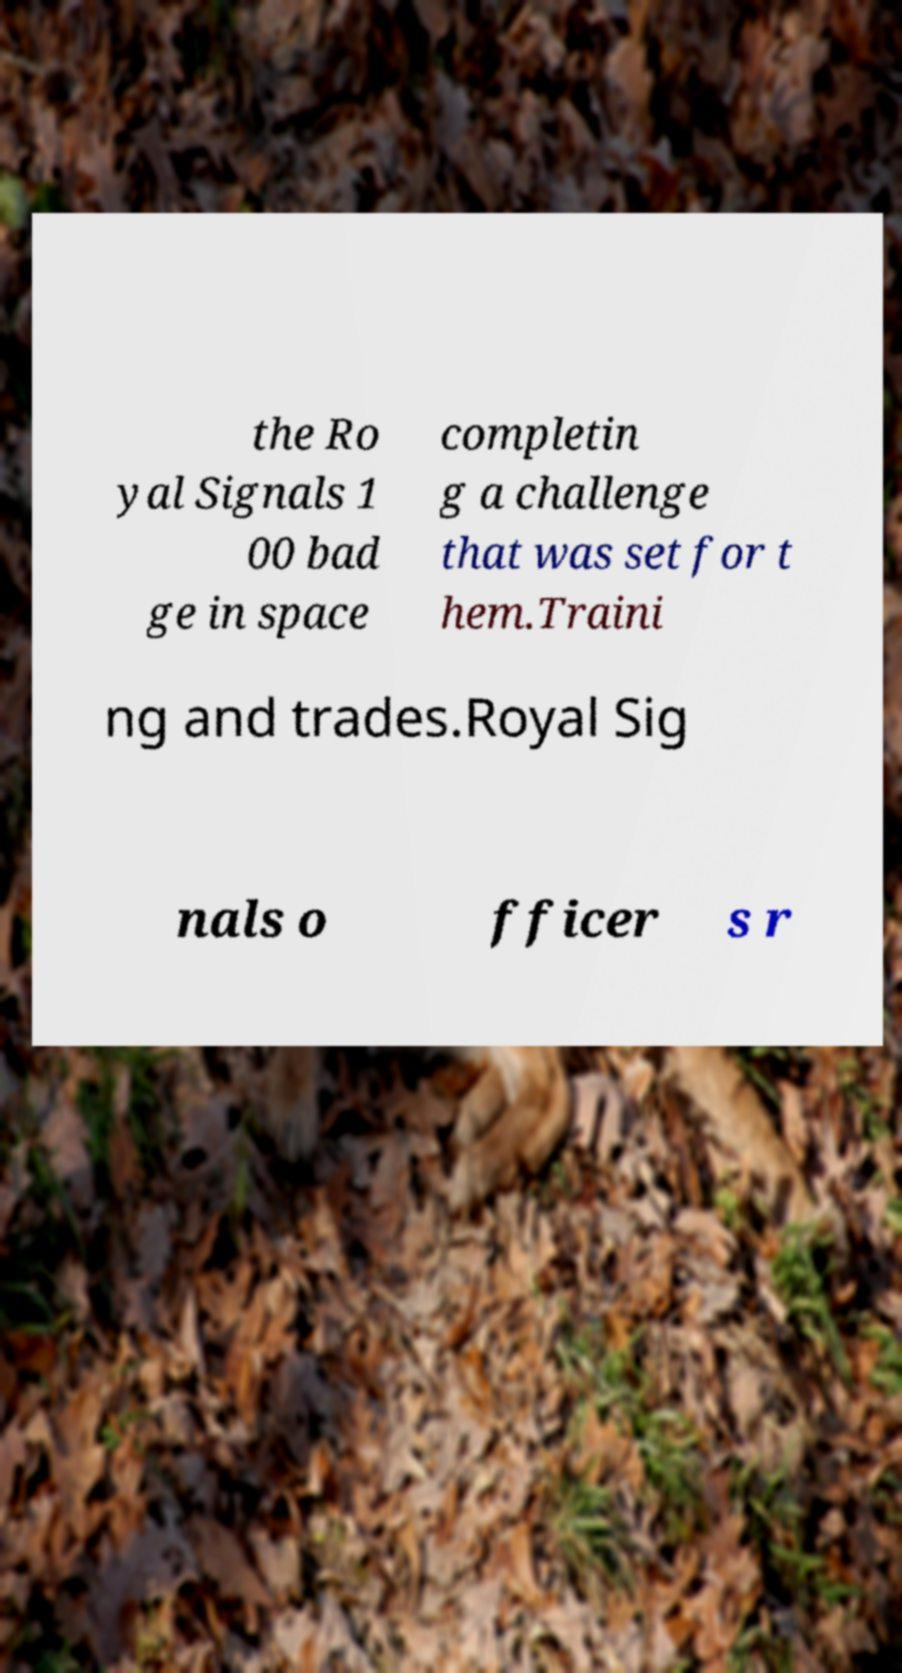For documentation purposes, I need the text within this image transcribed. Could you provide that? the Ro yal Signals 1 00 bad ge in space completin g a challenge that was set for t hem.Traini ng and trades.Royal Sig nals o fficer s r 